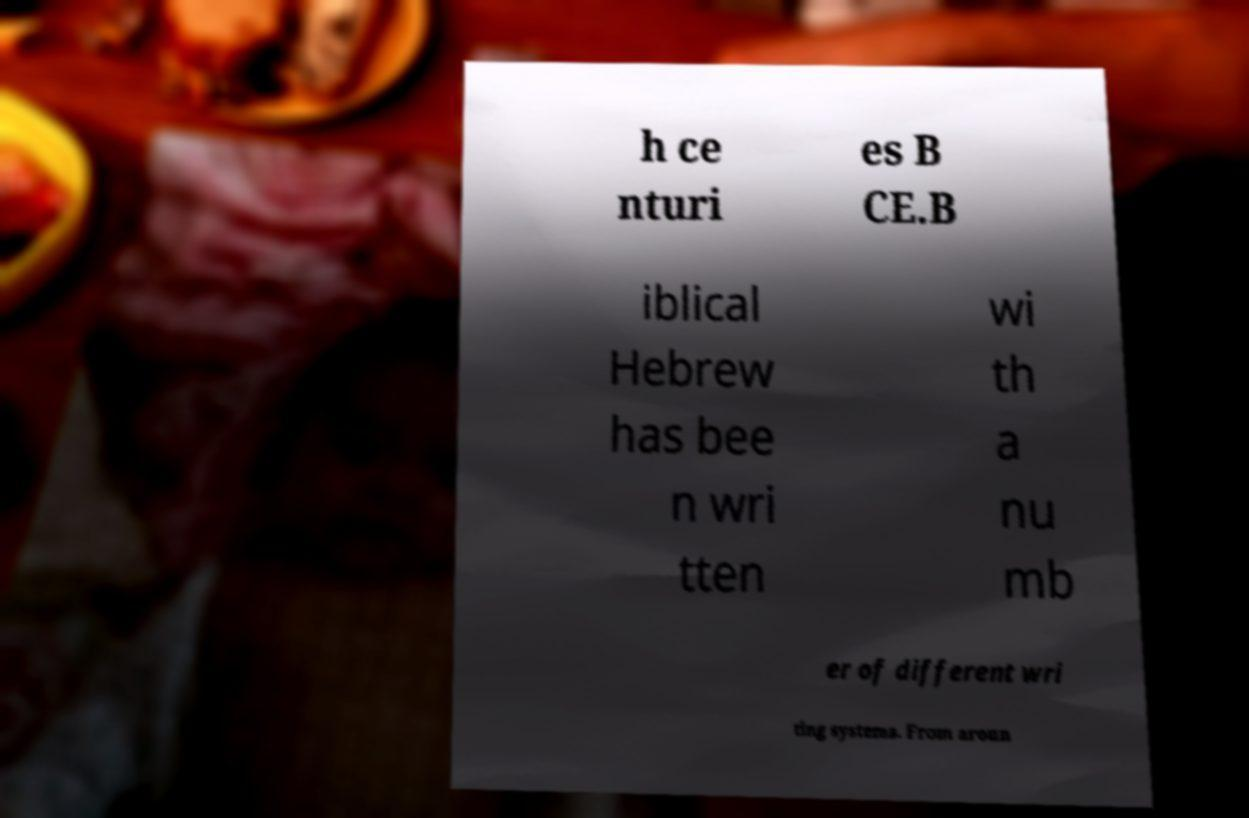What messages or text are displayed in this image? I need them in a readable, typed format. h ce nturi es B CE.B iblical Hebrew has bee n wri tten wi th a nu mb er of different wri ting systems. From aroun 